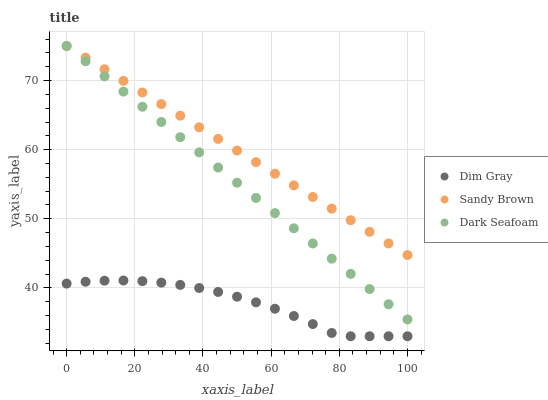Does Dim Gray have the minimum area under the curve?
Answer yes or no. Yes. Does Sandy Brown have the maximum area under the curve?
Answer yes or no. Yes. Does Sandy Brown have the minimum area under the curve?
Answer yes or no. No. Does Dim Gray have the maximum area under the curve?
Answer yes or no. No. Is Dark Seafoam the smoothest?
Answer yes or no. Yes. Is Dim Gray the roughest?
Answer yes or no. Yes. Is Sandy Brown the smoothest?
Answer yes or no. No. Is Sandy Brown the roughest?
Answer yes or no. No. Does Dim Gray have the lowest value?
Answer yes or no. Yes. Does Sandy Brown have the lowest value?
Answer yes or no. No. Does Sandy Brown have the highest value?
Answer yes or no. Yes. Does Dim Gray have the highest value?
Answer yes or no. No. Is Dim Gray less than Sandy Brown?
Answer yes or no. Yes. Is Sandy Brown greater than Dim Gray?
Answer yes or no. Yes. Does Sandy Brown intersect Dark Seafoam?
Answer yes or no. Yes. Is Sandy Brown less than Dark Seafoam?
Answer yes or no. No. Is Sandy Brown greater than Dark Seafoam?
Answer yes or no. No. Does Dim Gray intersect Sandy Brown?
Answer yes or no. No. 